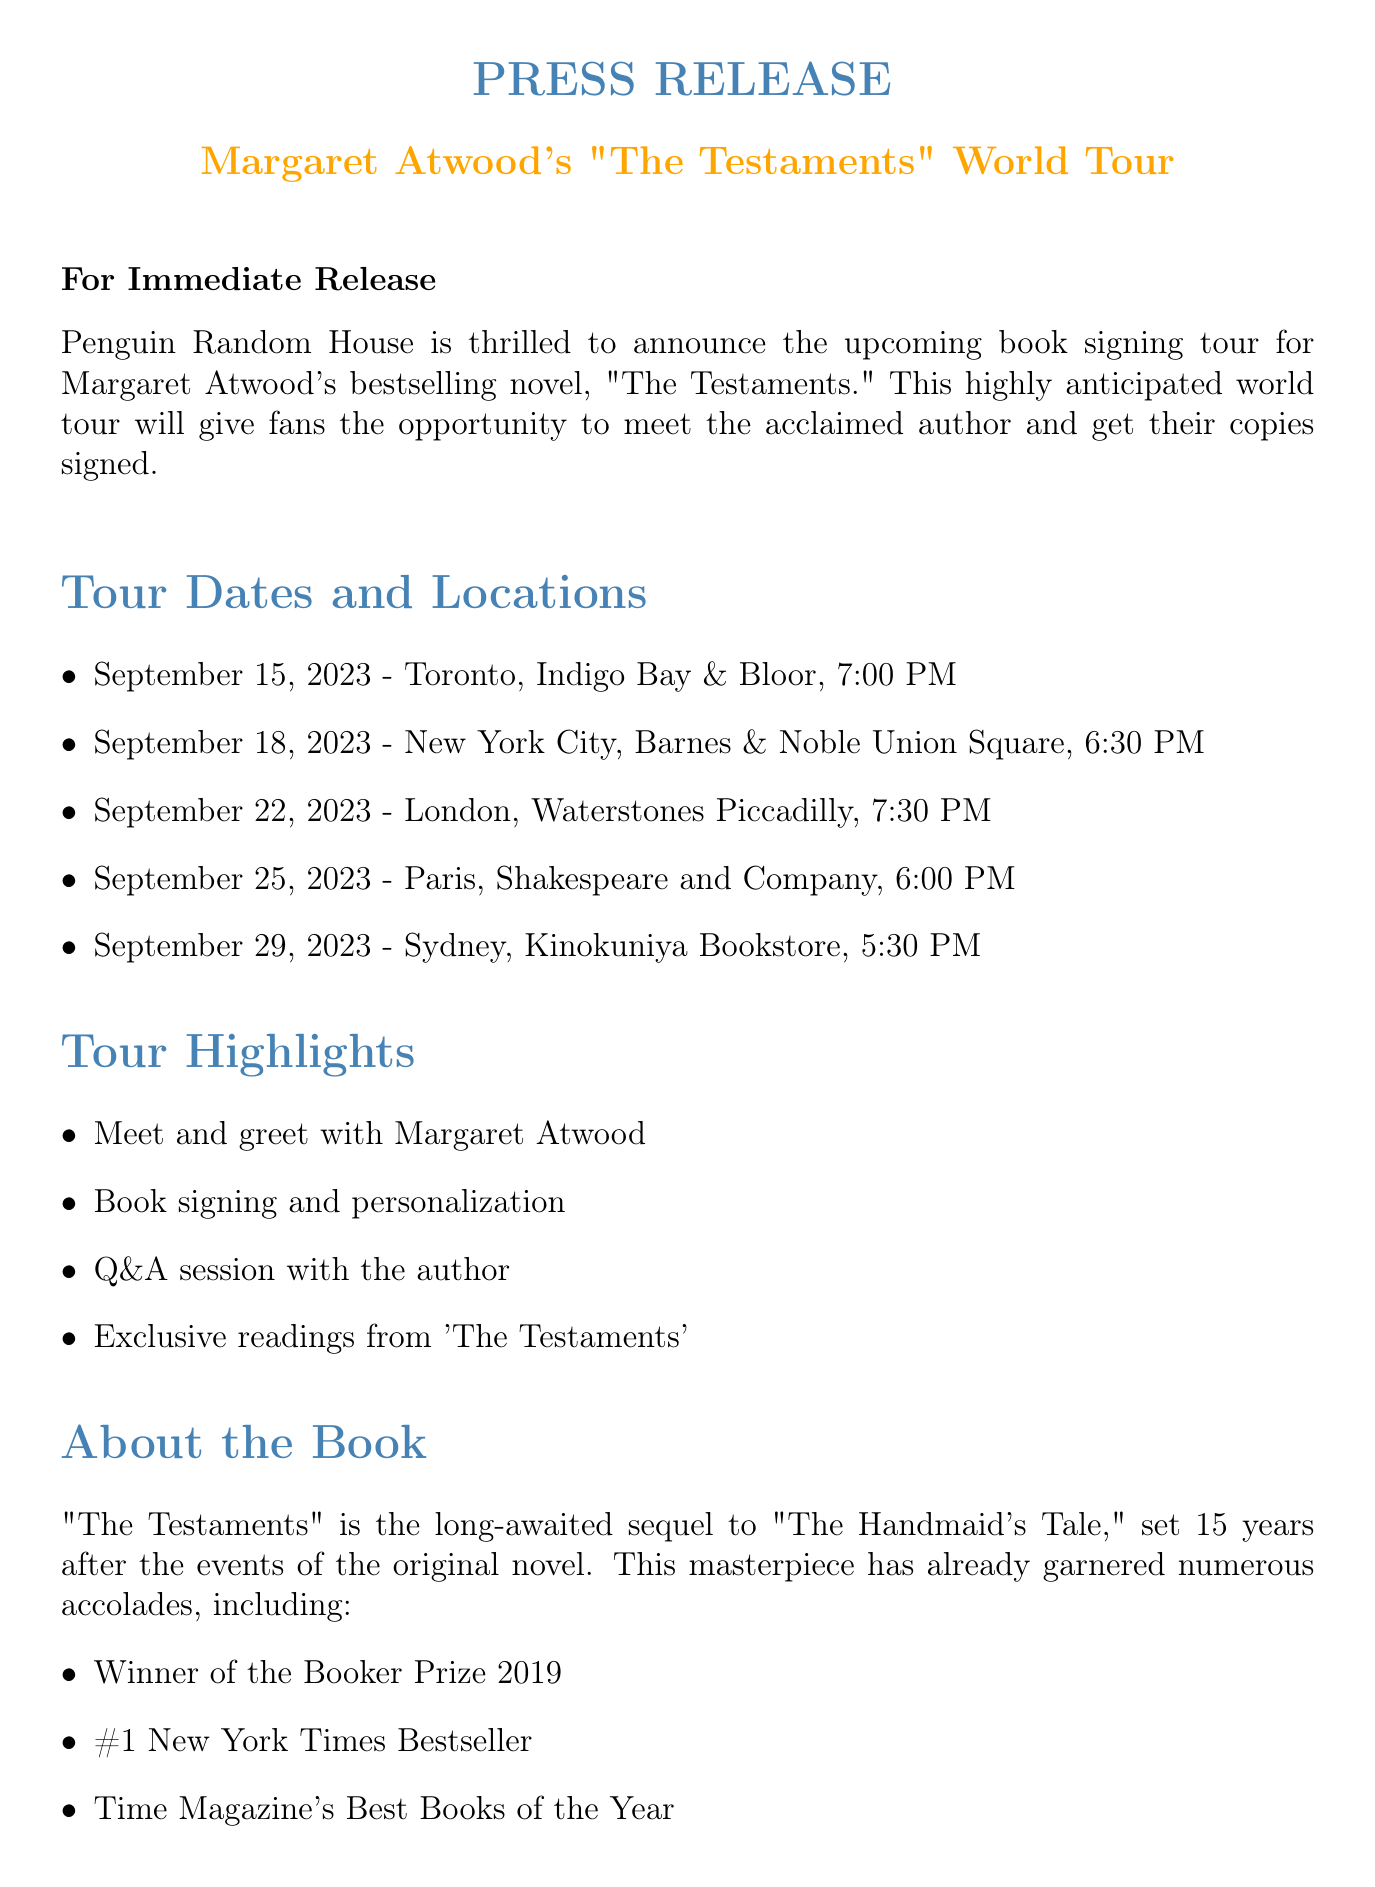What is the name of the author? The author's name is explicitly mentioned at the beginning of the document as Margaret Atwood.
Answer: Margaret Atwood What is the title of the book? The title of the book is stated in the introduction of the press release.
Answer: The Testaments How many tour dates are listed? The document provides a list of specific dates, and a count reveals there are five tour dates.
Answer: 5 On which date is the Sydney signing scheduled? The document specifies the date for the Sydney signing as part of the tour dates section.
Answer: September 29, 2023 What is the publisher's name? The publisher's name is mentioned in the introductory paragraph of the document.
Answer: Penguin Random House What is one highlight of the tour? The highlights section of the document lists activities, one of which is a meet and greet with the author.
Answer: Meet and greet with Margaret Atwood What is required for entry at the venues? The special instructions clearly state the entry requirements, including proof of book purchase.
Answer: Proof of book purchase What city has a signing event on September 18? The document explicitly states the city for the signing event on this date.
Answer: New York City What social media hashtag is associated with the tour? The document includes a specific hashtag for people to follow the tour on social media.
Answer: #TheTestamentsTour 